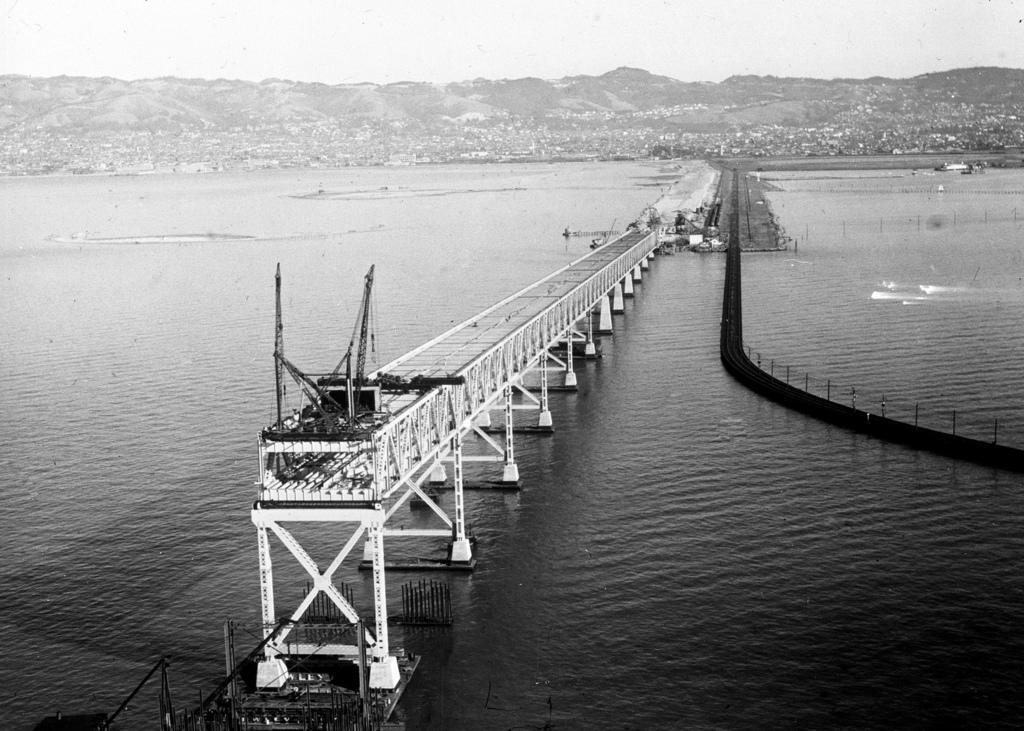How would you summarize this image in a sentence or two? It looks like a black and white picture. It is looking like a bridge in the water and behind the bridge there are hills and a sky. 